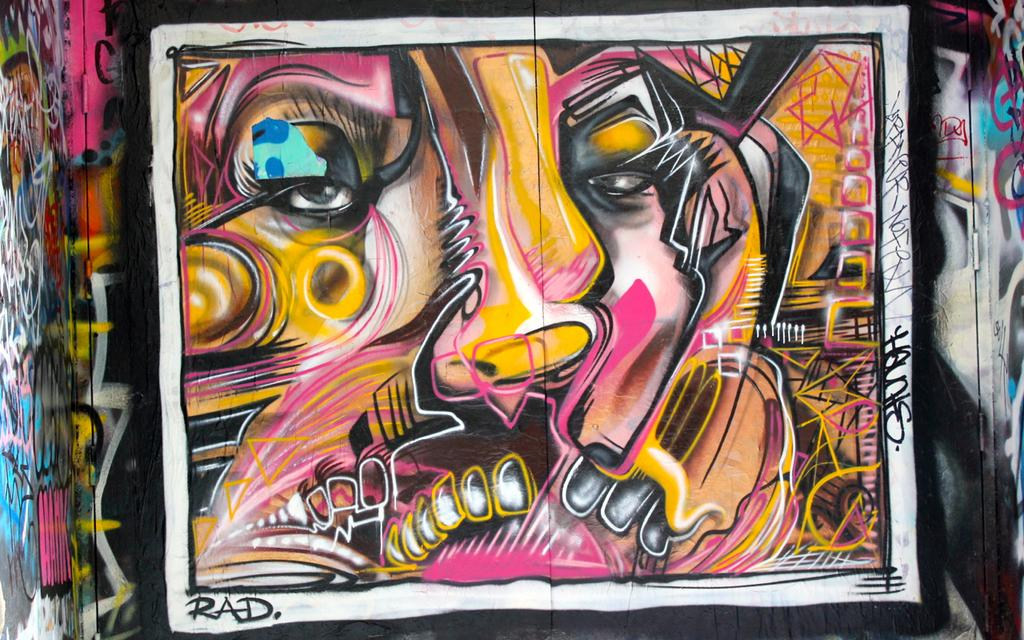What can be seen on the wall in the image? There is graffiti on a wall in the image. Can you describe the graffiti in more detail? Unfortunately, the facts provided do not give any specific details about the graffiti. What might be the purpose of the graffiti? The purpose of the graffiti cannot be determined from the image alone. What type of leather is being used to create the directional quartz in the image? There is no leather, directional quartz, or any indication of a quartz-related object in the image. 